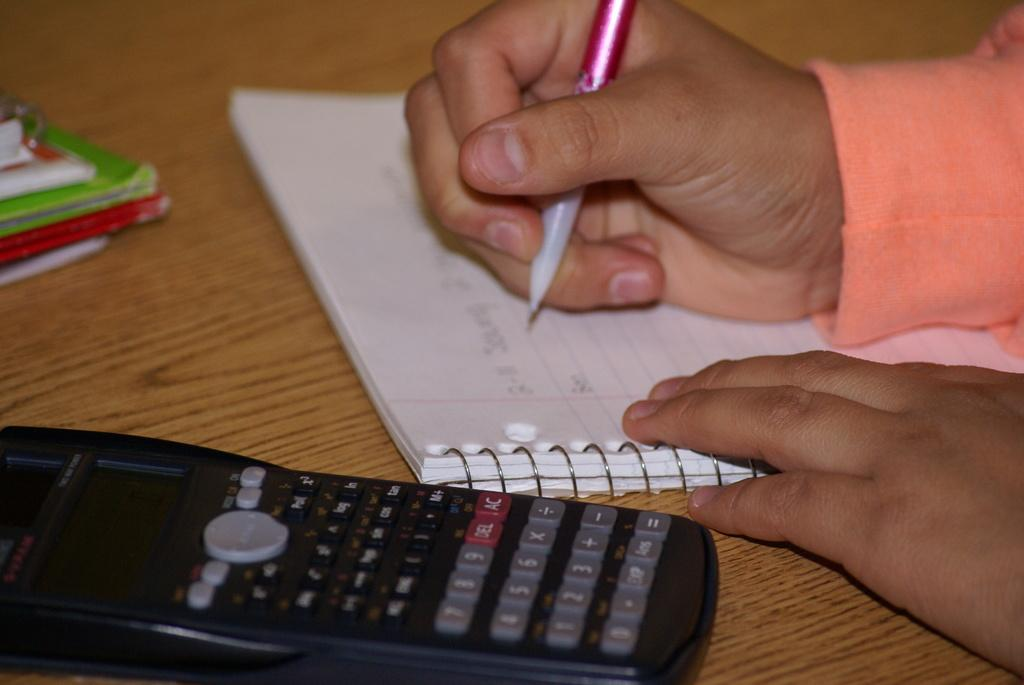<image>
Create a compact narrative representing the image presented. A calculator with a red delete button is on a table. 